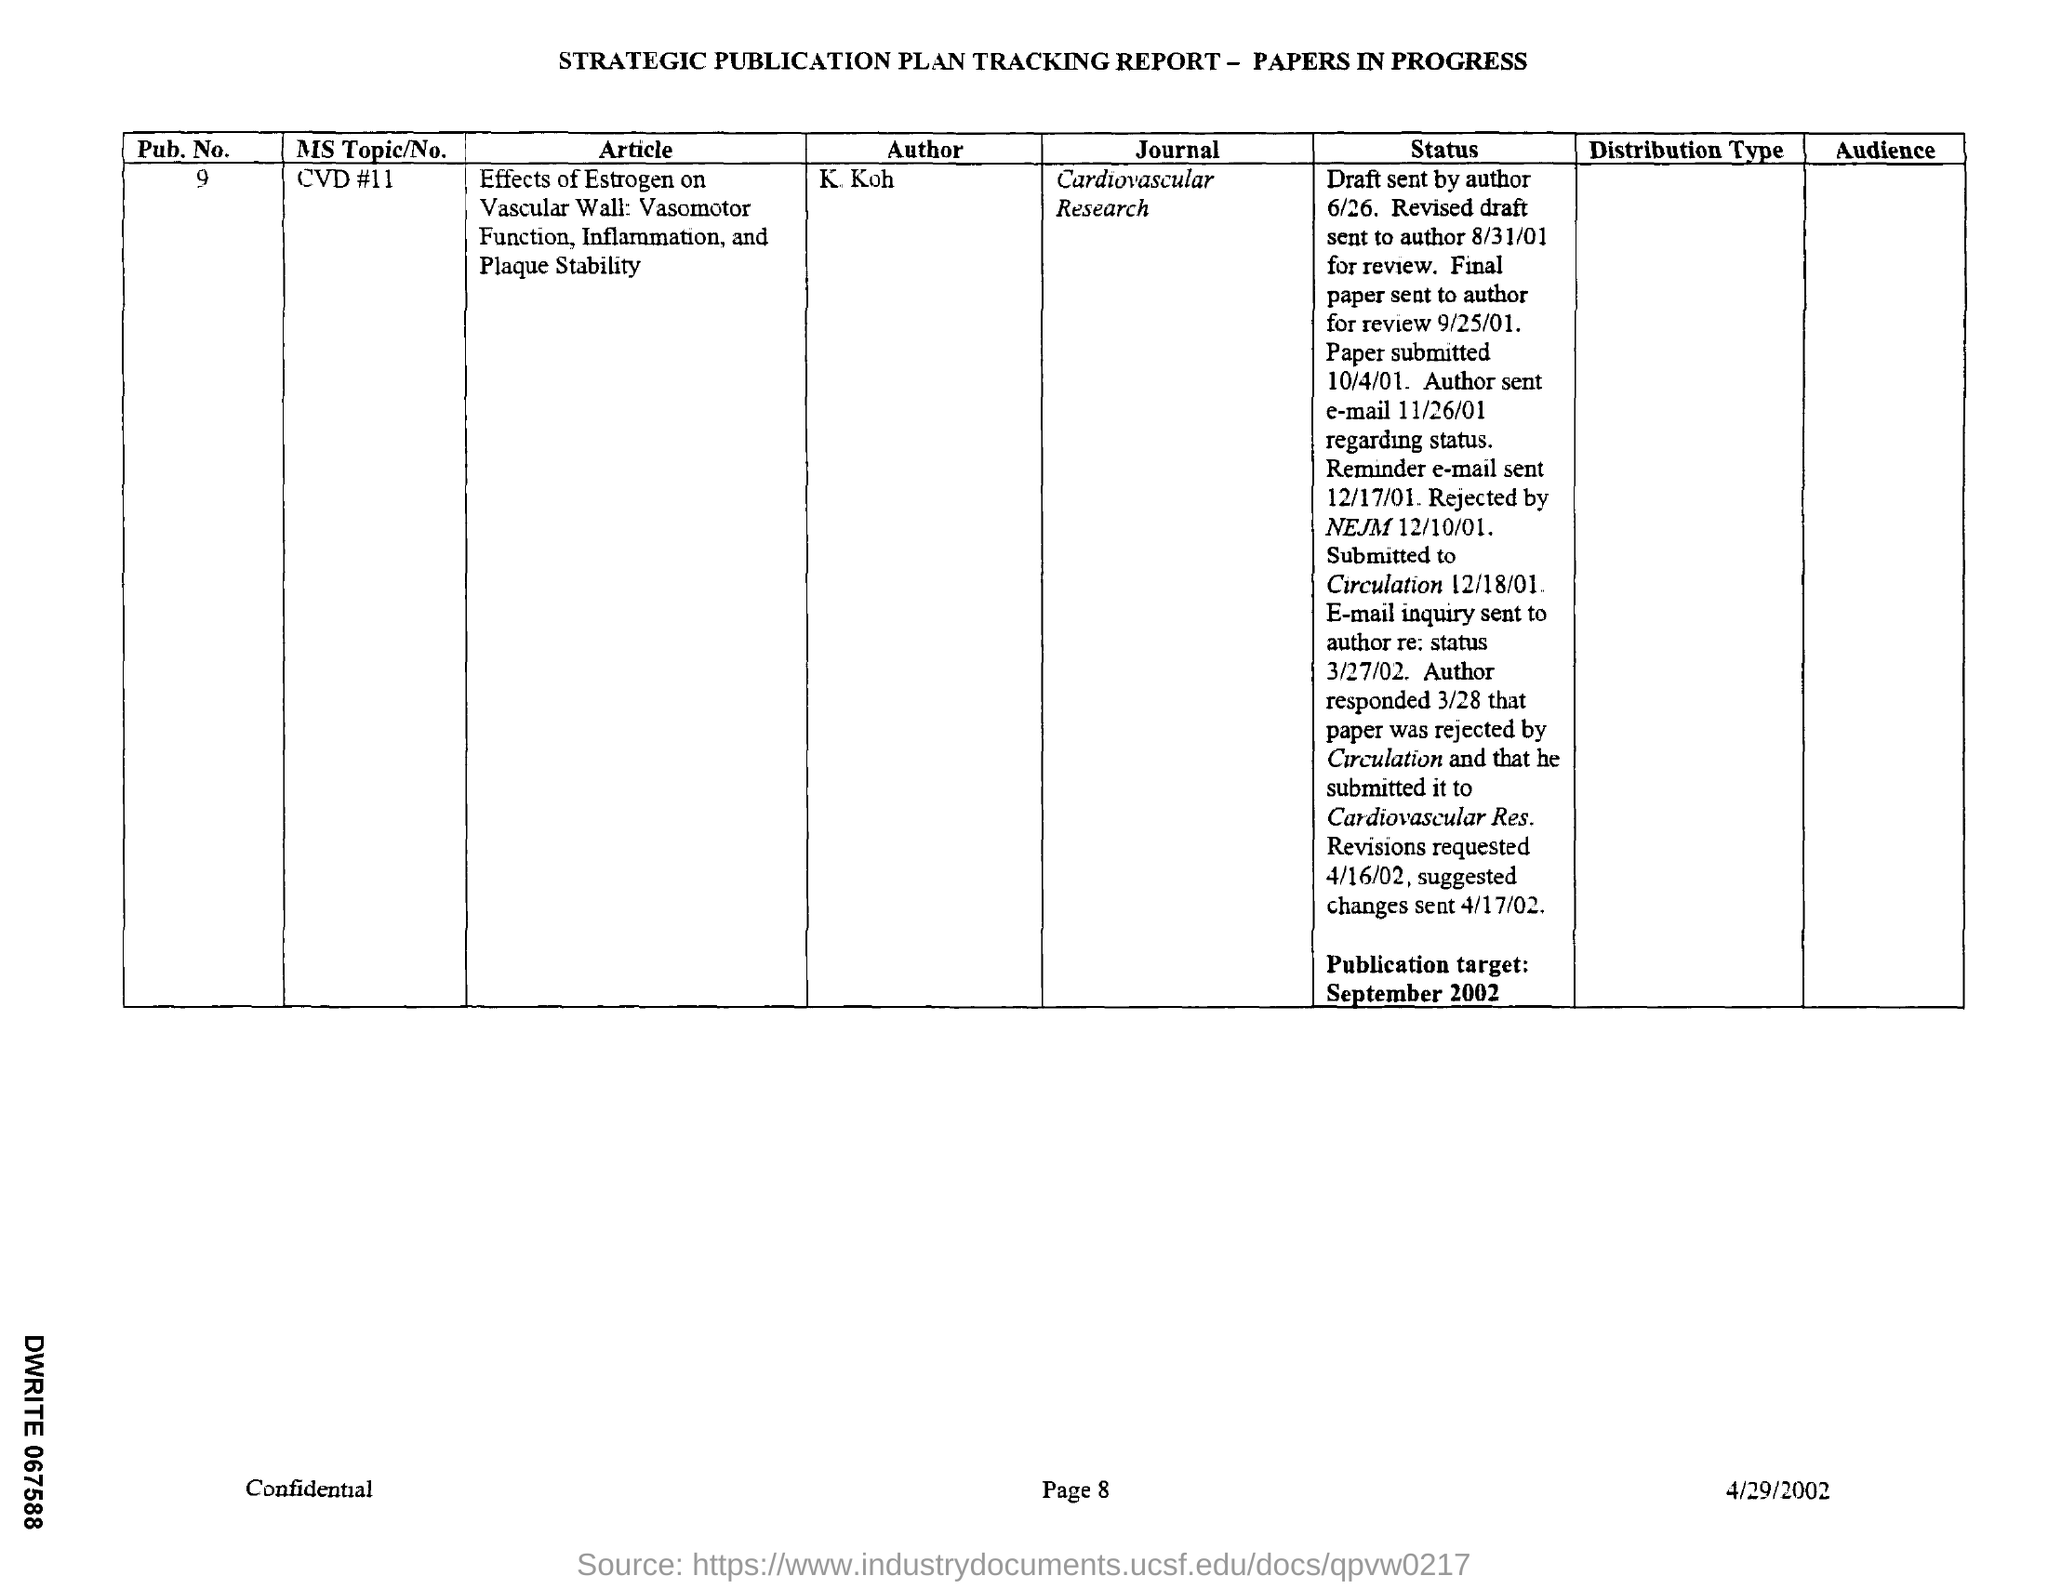List a handful of essential elements in this visual. The revised draft was sent to the author on August 31, 2001. The author sent an e-mail regarding the status on November 26, 2001. The name of the journal is Cardiovascular Research. The final paper was sent to the author for review on September 25, 2001. On December 17th, 2001, the reminder email was sent. 